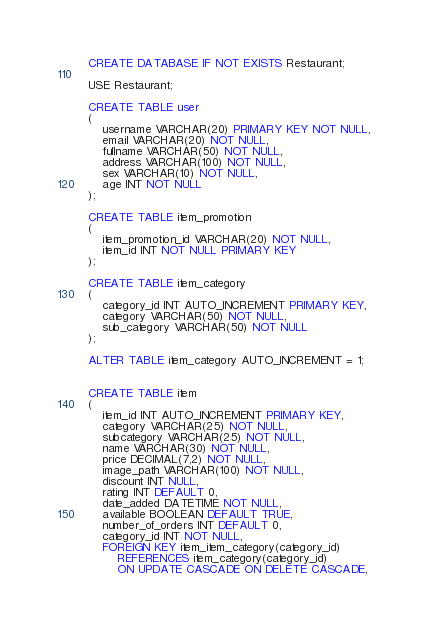<code> <loc_0><loc_0><loc_500><loc_500><_SQL_>CREATE DATABASE IF NOT EXISTS Restaurant;

USE Restaurant;

CREATE TABLE user
(
	username VARCHAR(20) PRIMARY KEY NOT NULL,
    email VARCHAR(20) NOT NULL,
    fullname VARCHAR(50) NOT NULL,
    address VARCHAR(100) NOT NULL,
    sex VARCHAR(10) NOT NULL, 
    age INT NOT NULL
);

CREATE TABLE item_promotion
(
	item_promotion_id VARCHAR(20) NOT NULL,
    item_id INT NOT NULL PRIMARY KEY
);

CREATE TABLE item_category
(
	category_id INT AUTO_INCREMENT PRIMARY KEY,
	category VARCHAR(50) NOT NULL,
    sub_category VARCHAR(50) NOT NULL
);

ALTER TABLE item_category AUTO_INCREMENT = 1;


CREATE TABLE item
(
	item_id INT AUTO_INCREMENT PRIMARY KEY,
    category VARCHAR(25) NOT NULL,
    subcategory VARCHAR(25) NOT NULL,
    name VARCHAR(30) NOT NULL,
    price DECIMAL(7,2) NOT NULL,
    image_path VARCHAR(100) NOT NULL,
    discount INT NULL,
    rating INT DEFAULT 0,
    date_added DATETIME NOT NULL,
    available BOOLEAN DEFAULT TRUE,
    number_of_orders INT DEFAULT 0,
    category_id INT NOT NULL,
    FOREIGN KEY item_item_category(category_id)
		REFERENCES item_category(category_id)
        ON UPDATE CASCADE ON DELETE CASCADE,</code> 